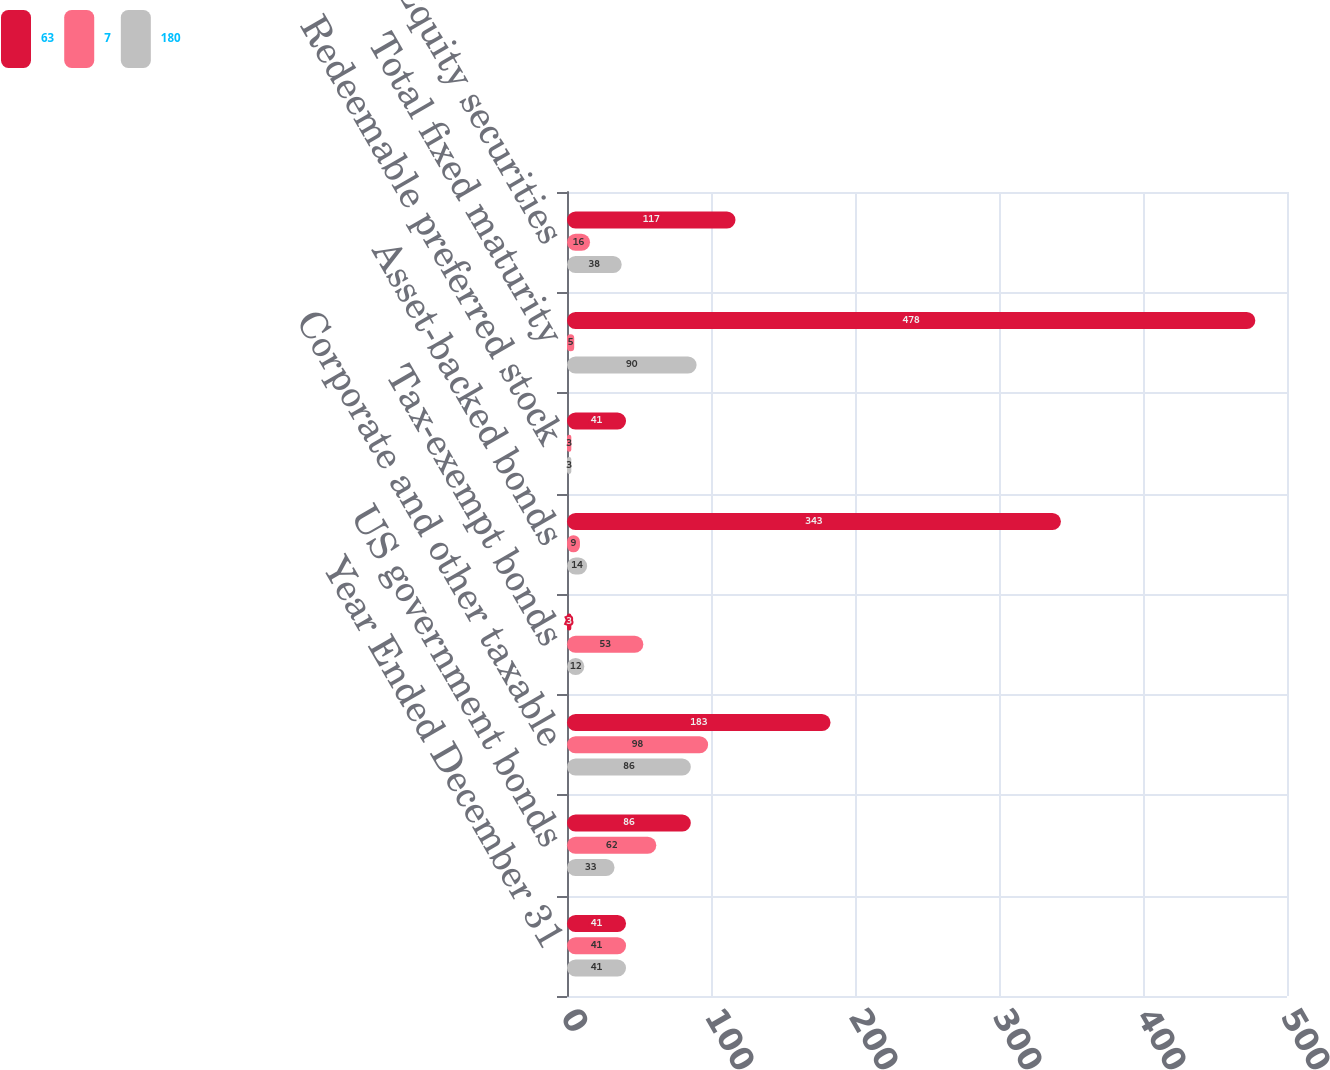<chart> <loc_0><loc_0><loc_500><loc_500><stacked_bar_chart><ecel><fcel>Year Ended December 31<fcel>US government bonds<fcel>Corporate and other taxable<fcel>Tax-exempt bonds<fcel>Asset-backed bonds<fcel>Redeemable preferred stock<fcel>Total fixed maturity<fcel>Equity securities<nl><fcel>63<fcel>41<fcel>86<fcel>183<fcel>3<fcel>343<fcel>41<fcel>478<fcel>117<nl><fcel>7<fcel>41<fcel>62<fcel>98<fcel>53<fcel>9<fcel>3<fcel>5<fcel>16<nl><fcel>180<fcel>41<fcel>33<fcel>86<fcel>12<fcel>14<fcel>3<fcel>90<fcel>38<nl></chart> 